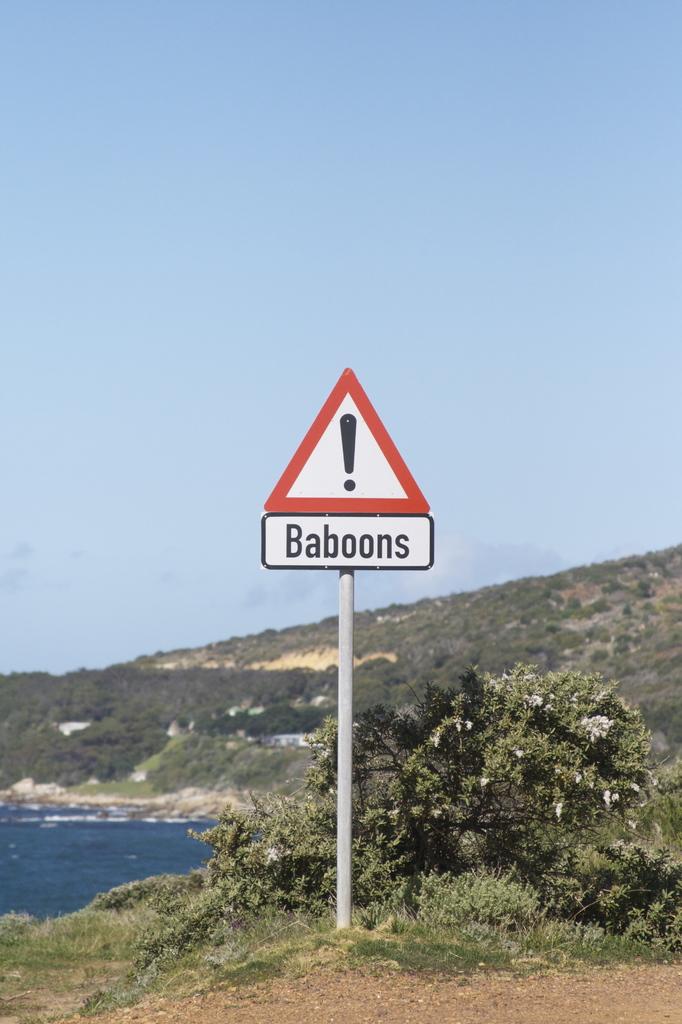What is the sign warning you of?
Keep it short and to the point. Baboons. What is the puncutation mark here?
Provide a succinct answer. !. 